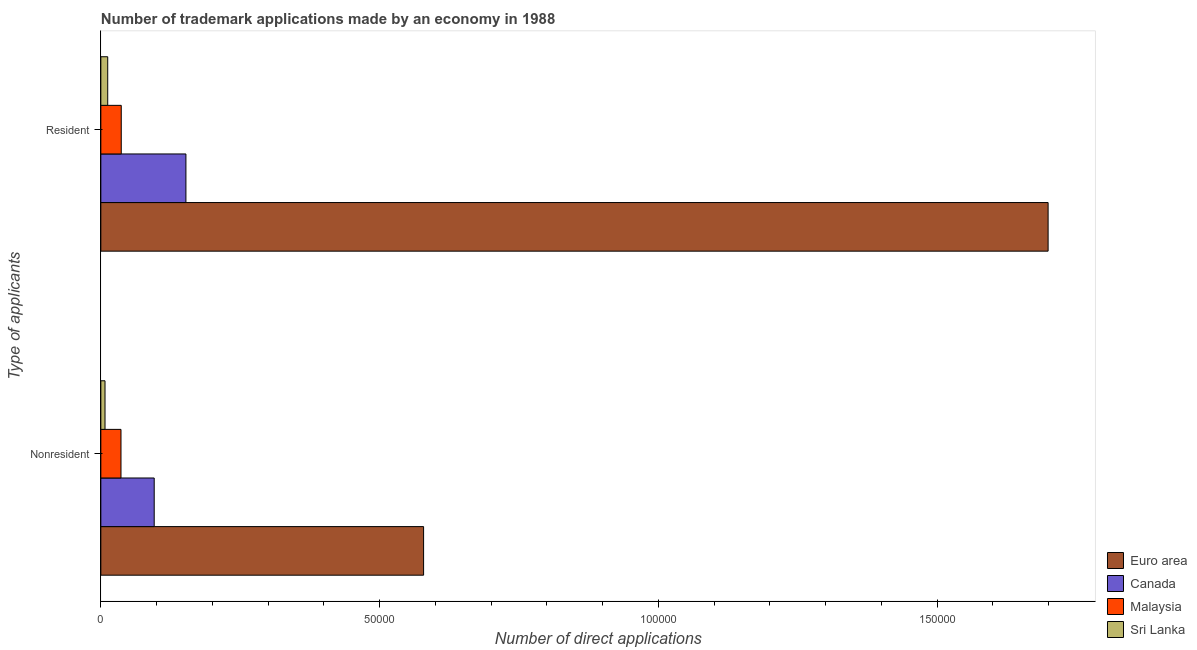How many different coloured bars are there?
Your answer should be compact. 4. What is the label of the 2nd group of bars from the top?
Offer a very short reply. Nonresident. What is the number of trademark applications made by residents in Euro area?
Your answer should be very brief. 1.70e+05. Across all countries, what is the maximum number of trademark applications made by residents?
Give a very brief answer. 1.70e+05. Across all countries, what is the minimum number of trademark applications made by non residents?
Provide a short and direct response. 750. In which country was the number of trademark applications made by residents maximum?
Offer a very short reply. Euro area. In which country was the number of trademark applications made by non residents minimum?
Keep it short and to the point. Sri Lanka. What is the total number of trademark applications made by non residents in the graph?
Ensure brevity in your answer.  7.18e+04. What is the difference between the number of trademark applications made by residents in Malaysia and that in Sri Lanka?
Offer a very short reply. 2428. What is the difference between the number of trademark applications made by residents in Malaysia and the number of trademark applications made by non residents in Canada?
Your response must be concise. -5910. What is the average number of trademark applications made by residents per country?
Keep it short and to the point. 4.75e+04. What is the difference between the number of trademark applications made by non residents and number of trademark applications made by residents in Malaysia?
Your answer should be compact. -50. In how many countries, is the number of trademark applications made by residents greater than 130000 ?
Your response must be concise. 1. What is the ratio of the number of trademark applications made by residents in Euro area to that in Canada?
Your response must be concise. 11.13. Is the number of trademark applications made by residents in Euro area less than that in Canada?
Make the answer very short. No. What does the 1st bar from the top in Resident represents?
Your response must be concise. Sri Lanka. How many bars are there?
Make the answer very short. 8. Are all the bars in the graph horizontal?
Provide a short and direct response. Yes. How many countries are there in the graph?
Offer a terse response. 4. What is the difference between two consecutive major ticks on the X-axis?
Keep it short and to the point. 5.00e+04. Does the graph contain grids?
Ensure brevity in your answer.  No. How many legend labels are there?
Give a very brief answer. 4. How are the legend labels stacked?
Offer a very short reply. Vertical. What is the title of the graph?
Your answer should be very brief. Number of trademark applications made by an economy in 1988. Does "China" appear as one of the legend labels in the graph?
Your answer should be very brief. No. What is the label or title of the X-axis?
Keep it short and to the point. Number of direct applications. What is the label or title of the Y-axis?
Ensure brevity in your answer.  Type of applicants. What is the Number of direct applications in Euro area in Nonresident?
Make the answer very short. 5.79e+04. What is the Number of direct applications in Canada in Nonresident?
Your answer should be very brief. 9572. What is the Number of direct applications in Malaysia in Nonresident?
Provide a succinct answer. 3612. What is the Number of direct applications of Sri Lanka in Nonresident?
Your answer should be very brief. 750. What is the Number of direct applications in Euro area in Resident?
Make the answer very short. 1.70e+05. What is the Number of direct applications in Canada in Resident?
Provide a short and direct response. 1.53e+04. What is the Number of direct applications of Malaysia in Resident?
Your answer should be compact. 3662. What is the Number of direct applications of Sri Lanka in Resident?
Give a very brief answer. 1234. Across all Type of applicants, what is the maximum Number of direct applications of Euro area?
Make the answer very short. 1.70e+05. Across all Type of applicants, what is the maximum Number of direct applications of Canada?
Your answer should be very brief. 1.53e+04. Across all Type of applicants, what is the maximum Number of direct applications of Malaysia?
Your response must be concise. 3662. Across all Type of applicants, what is the maximum Number of direct applications in Sri Lanka?
Offer a terse response. 1234. Across all Type of applicants, what is the minimum Number of direct applications of Euro area?
Make the answer very short. 5.79e+04. Across all Type of applicants, what is the minimum Number of direct applications in Canada?
Keep it short and to the point. 9572. Across all Type of applicants, what is the minimum Number of direct applications of Malaysia?
Ensure brevity in your answer.  3612. Across all Type of applicants, what is the minimum Number of direct applications in Sri Lanka?
Give a very brief answer. 750. What is the total Number of direct applications of Euro area in the graph?
Give a very brief answer. 2.28e+05. What is the total Number of direct applications in Canada in the graph?
Provide a succinct answer. 2.48e+04. What is the total Number of direct applications of Malaysia in the graph?
Provide a short and direct response. 7274. What is the total Number of direct applications of Sri Lanka in the graph?
Keep it short and to the point. 1984. What is the difference between the Number of direct applications of Euro area in Nonresident and that in Resident?
Make the answer very short. -1.12e+05. What is the difference between the Number of direct applications in Canada in Nonresident and that in Resident?
Provide a short and direct response. -5690. What is the difference between the Number of direct applications of Sri Lanka in Nonresident and that in Resident?
Your answer should be very brief. -484. What is the difference between the Number of direct applications of Euro area in Nonresident and the Number of direct applications of Canada in Resident?
Provide a short and direct response. 4.26e+04. What is the difference between the Number of direct applications in Euro area in Nonresident and the Number of direct applications in Malaysia in Resident?
Provide a succinct answer. 5.42e+04. What is the difference between the Number of direct applications in Euro area in Nonresident and the Number of direct applications in Sri Lanka in Resident?
Offer a very short reply. 5.67e+04. What is the difference between the Number of direct applications in Canada in Nonresident and the Number of direct applications in Malaysia in Resident?
Make the answer very short. 5910. What is the difference between the Number of direct applications of Canada in Nonresident and the Number of direct applications of Sri Lanka in Resident?
Your response must be concise. 8338. What is the difference between the Number of direct applications in Malaysia in Nonresident and the Number of direct applications in Sri Lanka in Resident?
Offer a very short reply. 2378. What is the average Number of direct applications in Euro area per Type of applicants?
Your answer should be compact. 1.14e+05. What is the average Number of direct applications in Canada per Type of applicants?
Keep it short and to the point. 1.24e+04. What is the average Number of direct applications in Malaysia per Type of applicants?
Keep it short and to the point. 3637. What is the average Number of direct applications in Sri Lanka per Type of applicants?
Offer a very short reply. 992. What is the difference between the Number of direct applications of Euro area and Number of direct applications of Canada in Nonresident?
Your answer should be very brief. 4.83e+04. What is the difference between the Number of direct applications in Euro area and Number of direct applications in Malaysia in Nonresident?
Give a very brief answer. 5.43e+04. What is the difference between the Number of direct applications of Euro area and Number of direct applications of Sri Lanka in Nonresident?
Keep it short and to the point. 5.72e+04. What is the difference between the Number of direct applications of Canada and Number of direct applications of Malaysia in Nonresident?
Your answer should be very brief. 5960. What is the difference between the Number of direct applications in Canada and Number of direct applications in Sri Lanka in Nonresident?
Your answer should be compact. 8822. What is the difference between the Number of direct applications in Malaysia and Number of direct applications in Sri Lanka in Nonresident?
Keep it short and to the point. 2862. What is the difference between the Number of direct applications in Euro area and Number of direct applications in Canada in Resident?
Your answer should be compact. 1.55e+05. What is the difference between the Number of direct applications of Euro area and Number of direct applications of Malaysia in Resident?
Provide a succinct answer. 1.66e+05. What is the difference between the Number of direct applications of Euro area and Number of direct applications of Sri Lanka in Resident?
Make the answer very short. 1.69e+05. What is the difference between the Number of direct applications of Canada and Number of direct applications of Malaysia in Resident?
Provide a short and direct response. 1.16e+04. What is the difference between the Number of direct applications in Canada and Number of direct applications in Sri Lanka in Resident?
Give a very brief answer. 1.40e+04. What is the difference between the Number of direct applications in Malaysia and Number of direct applications in Sri Lanka in Resident?
Your answer should be very brief. 2428. What is the ratio of the Number of direct applications in Euro area in Nonresident to that in Resident?
Your response must be concise. 0.34. What is the ratio of the Number of direct applications in Canada in Nonresident to that in Resident?
Offer a terse response. 0.63. What is the ratio of the Number of direct applications in Malaysia in Nonresident to that in Resident?
Make the answer very short. 0.99. What is the ratio of the Number of direct applications of Sri Lanka in Nonresident to that in Resident?
Ensure brevity in your answer.  0.61. What is the difference between the highest and the second highest Number of direct applications of Euro area?
Offer a terse response. 1.12e+05. What is the difference between the highest and the second highest Number of direct applications of Canada?
Ensure brevity in your answer.  5690. What is the difference between the highest and the second highest Number of direct applications of Sri Lanka?
Your answer should be very brief. 484. What is the difference between the highest and the lowest Number of direct applications of Euro area?
Your answer should be very brief. 1.12e+05. What is the difference between the highest and the lowest Number of direct applications in Canada?
Offer a very short reply. 5690. What is the difference between the highest and the lowest Number of direct applications of Sri Lanka?
Provide a succinct answer. 484. 